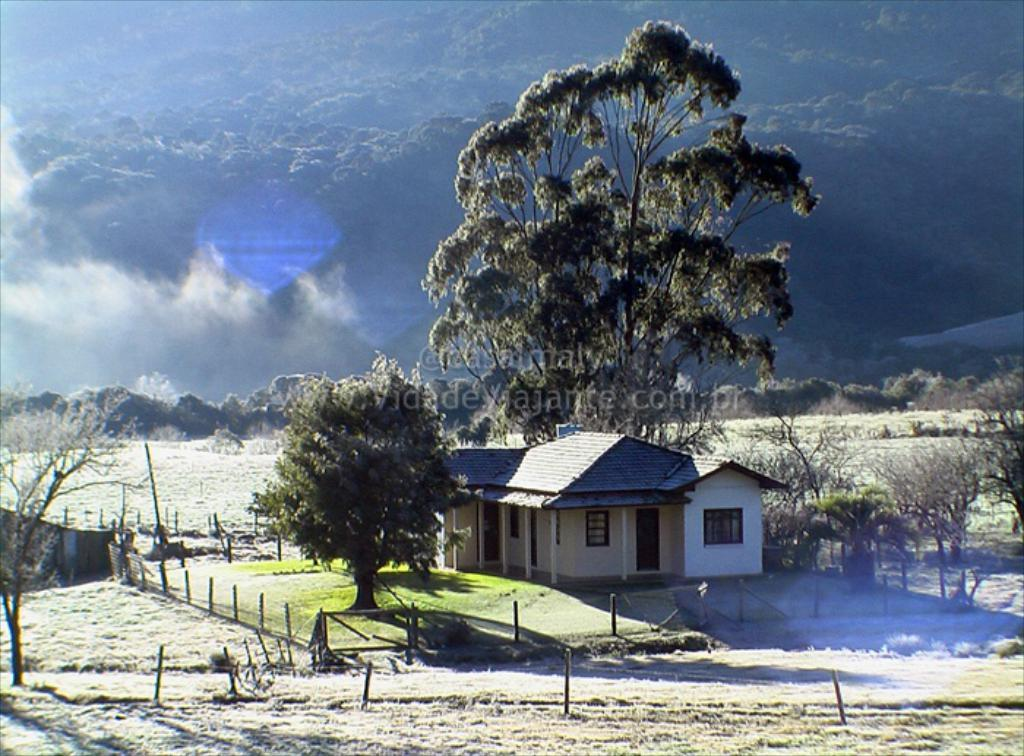What can be seen in the foreground of the image? In the foreground of the image, there is grass, a fence, trees, houses, and a text. Can you describe the elements in the foreground in more detail? The grass is green, the fence is made of wood, the trees are tall and leafy, the houses are brick-built, and the text appears to be a sign or label. What is visible in the background of the image? In the background of the image, there is smoke and mountains. How does the image appear in terms of editing or manipulation? The image appears to be an edited photo. Can you see any spring flowers blooming in the image? There is no mention of spring flowers in the image, and the presence of grass and trees does not necessarily indicate the presence of spring flowers. Is there a kite flying in the image? There is no mention of a kite in the image, and the presence of smoke and mountains in the background does not suggest the presence of a kite. 